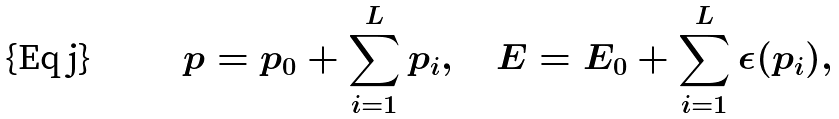Convert formula to latex. <formula><loc_0><loc_0><loc_500><loc_500>p = p _ { 0 } + \sum _ { i = 1 } ^ { L } p _ { i } , \quad E = E _ { 0 } + \sum _ { i = 1 } ^ { L } \epsilon ( p _ { i } ) ,</formula> 